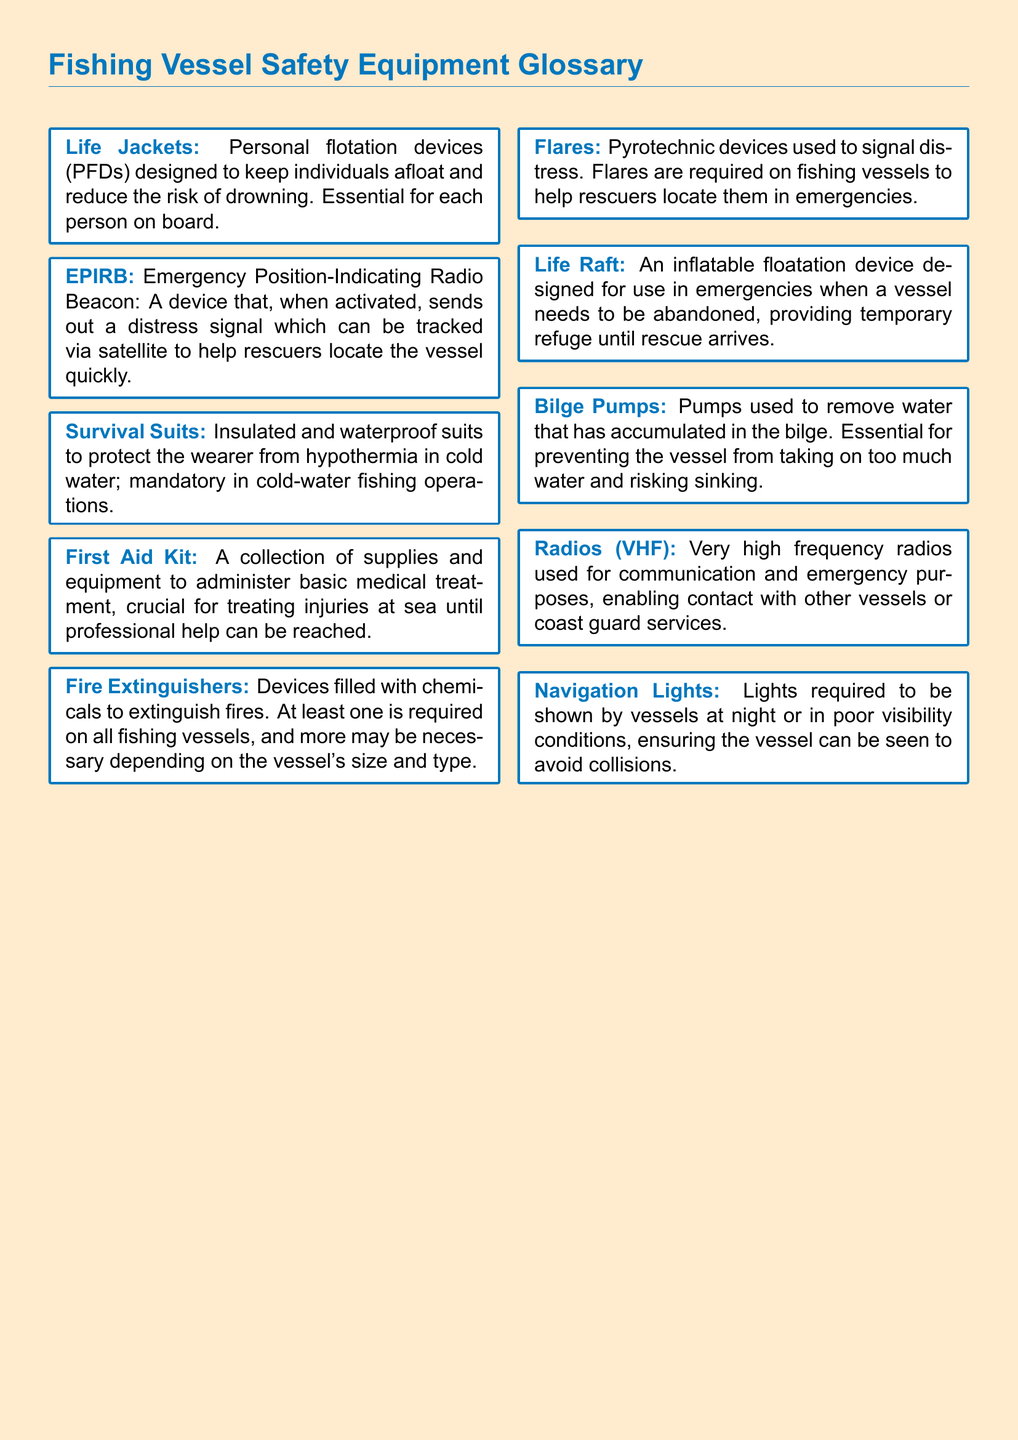What are Life Jackets? The document defines Life Jackets as personal flotation devices designed to keep individuals afloat and reduce the risk of drowning.
Answer: Personal flotation devices What is an EPIRB? According to the glossary, an EPIRB is a device that sends out a distress signal that can be tracked via satellite.
Answer: Emergency Position-Indicating Radio Beacon How many Fire Extinguishers are required on fishing vessels? The document states that at least one fire extinguisher is required on all fishing vessels.
Answer: At least one What do Survival Suits protect against? The glossary explains that Survival Suits protect the wearer from hypothermia in cold water.
Answer: Hypothermia What is the purpose of Flares? The document describes Flares as pyrotechnic devices used to signal distress and help rescuers locate fishing vessels.
Answer: Signal distress What equipment is crucial for treating injuries at sea? The glossary identifies the First Aid Kit as essential for administering basic medical treatment at sea.
Answer: First Aid Kit What are Radios (VHF) used for? The document mentions that Radios (VHF) are used for communication and emergency purposes, enabling contact with others.
Answer: Communication and emergency Why are Navigation Lights required? The document states that Navigation Lights are required to ensure the vessel can be seen to avoid collisions at night or in poor visibility.
Answer: Avoid collisions What device is designed for use in emergencies when a vessel needs to be abandoned? According to the glossary, a Life Raft is designed for this purpose.
Answer: Life Raft 